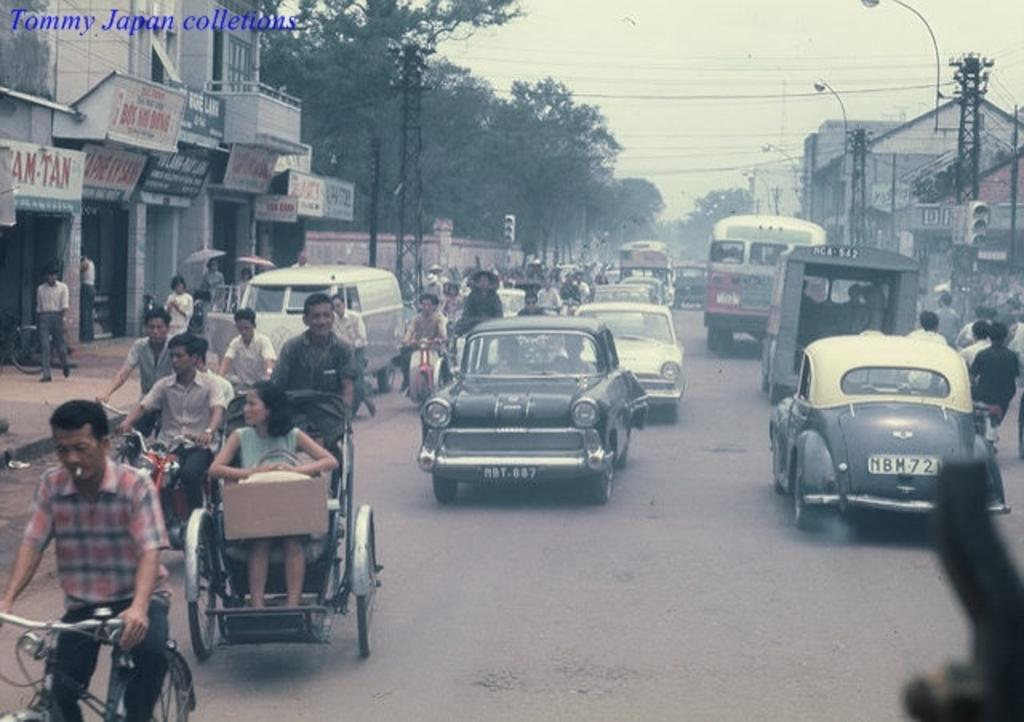What types of vehicles can be seen in the image? Cars, buses, and bicycles are visible in the image. What structures are present in the image? There are towers in the image. What additional elements can be seen in the image? Cables are present in the image. What is visible in the background of the image? The sky is visible in the image. What type of vegetation is present in the image? Trees are present in the image. What type of brick is used to build the home in the image? There is no home present in the image; it features vehicles, towers, cables, the sky, and trees. What is the wish of the person standing next to the bicycle in the image? There is no person standing next to the bicycle in the image, and therefore no wish can be attributed to them. 